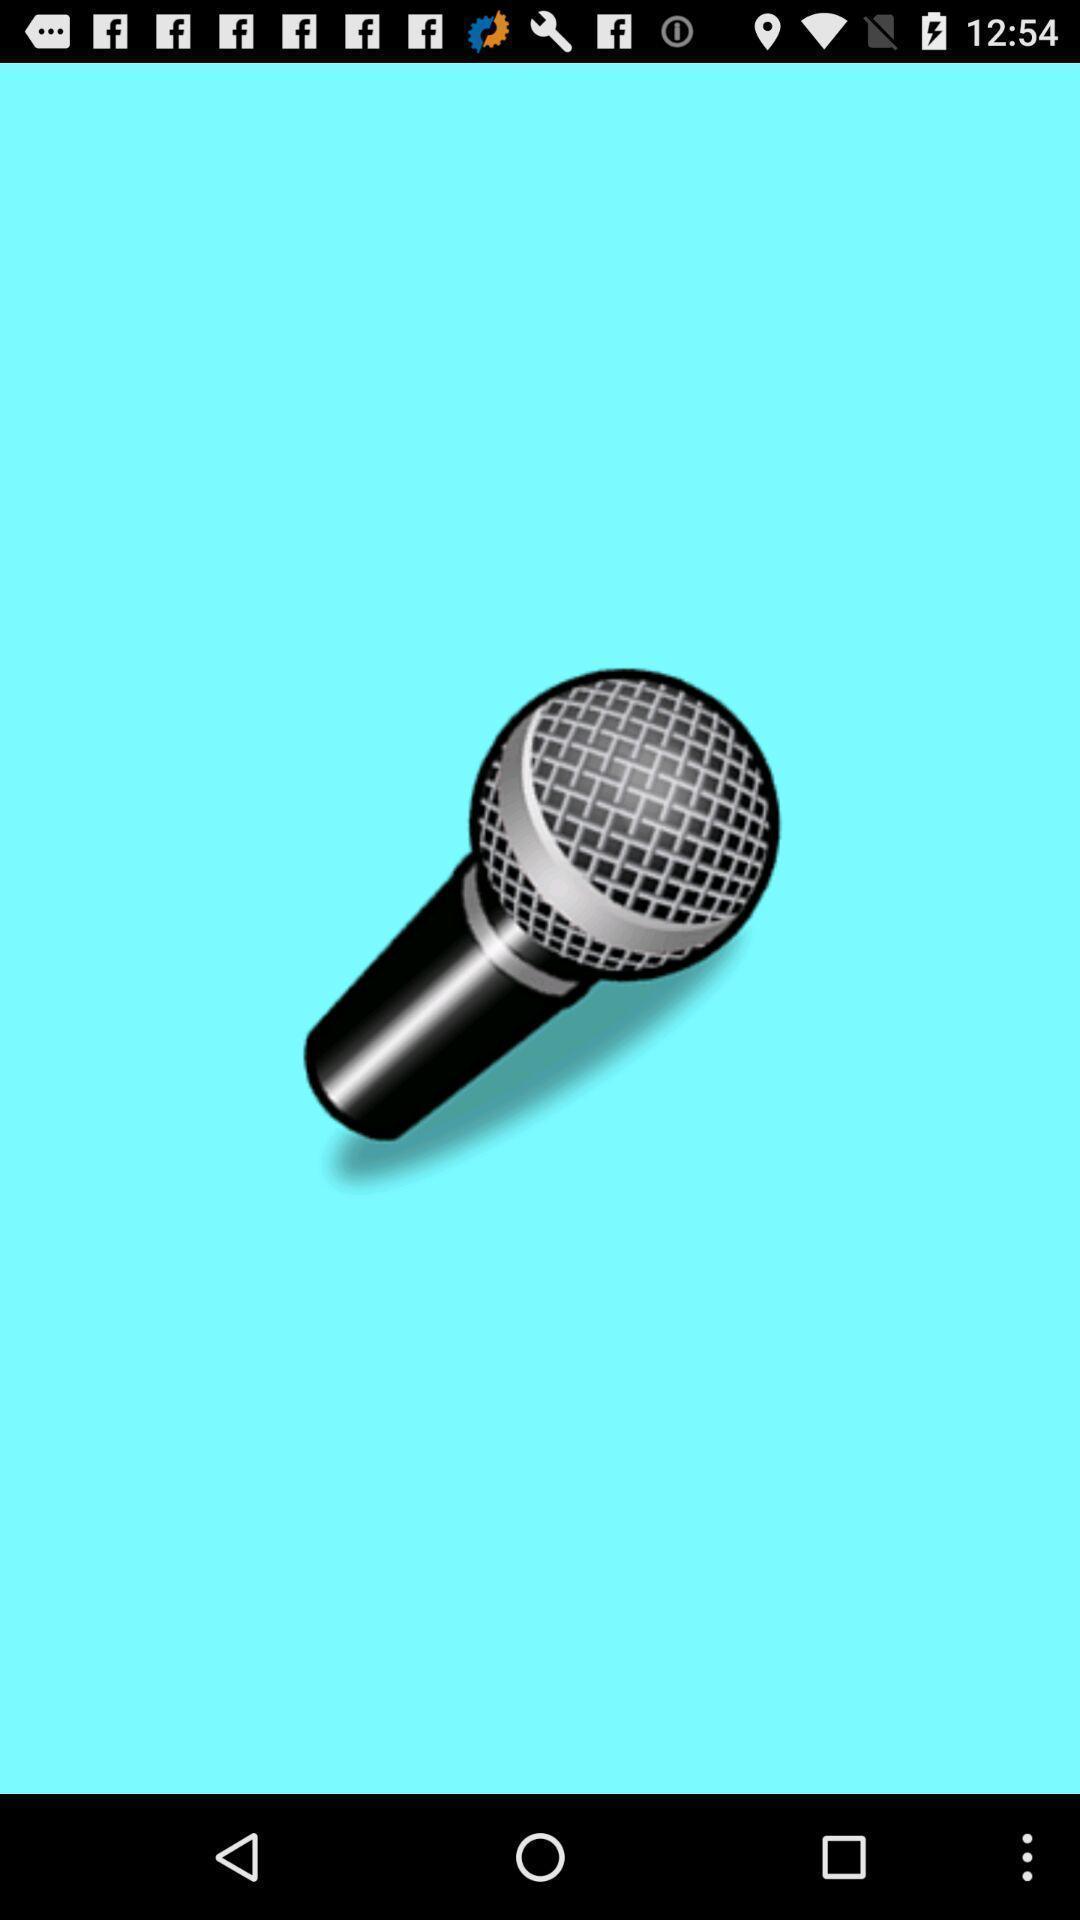Explain what's happening in this screen capture. Picture of mic. 